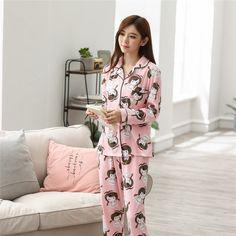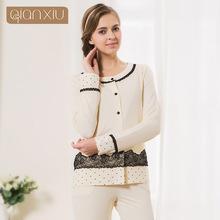The first image is the image on the left, the second image is the image on the right. Given the left and right images, does the statement "All of the girls are wearing pajamas with cartoon characters on them." hold true? Answer yes or no. No. The first image is the image on the left, the second image is the image on the right. Examine the images to the left and right. Is the description "Both girls are standing up but only one of them is touching her face." accurate? Answer yes or no. Yes. 